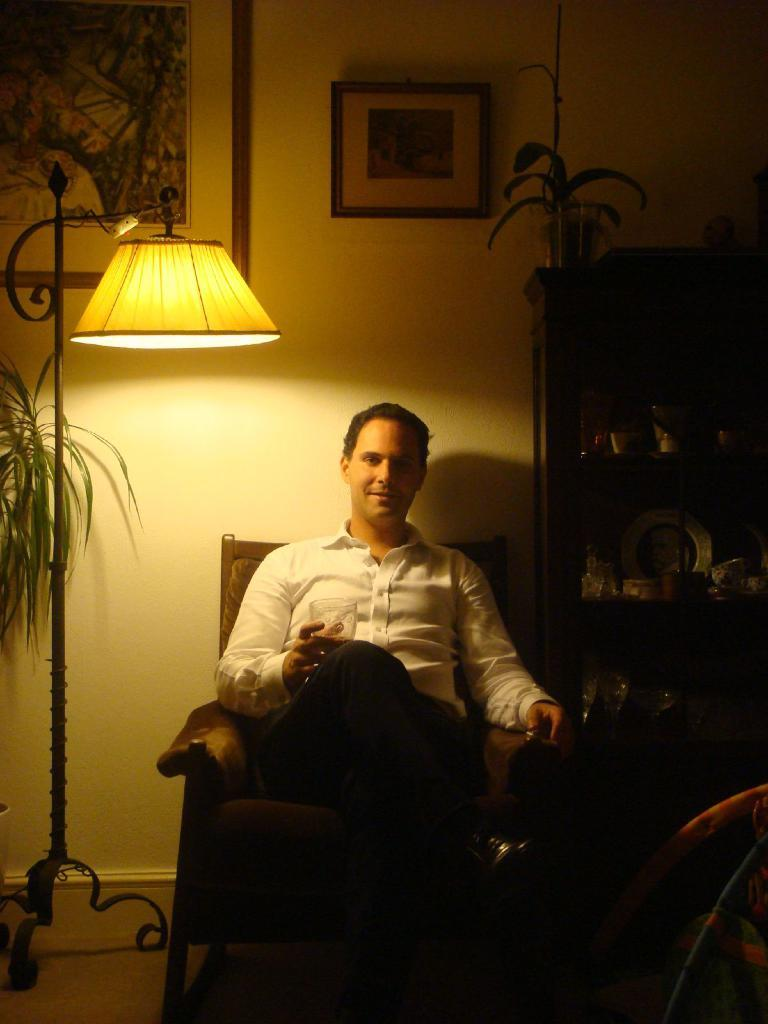What type of structure can be seen in the image? There is a wall in the image. What object provides light in the image? There is a lamp in the image. What items are used for displaying photos in the image? There are photo frames in the image. What is used for hanging or storing items in the image? There is a rack in the image. What type of plant is present in the image? There is a plant in the image. Is there a person in the image? Yes, there is a person in the image. What color is the shirt the person is wearing? The person is wearing a white color shirt. What is the person doing in the image? The person is sitting on a chair. What type of soap is the person using in the image? There is no soap present in the image; the person is sitting on a chair wearing a white color shirt. 